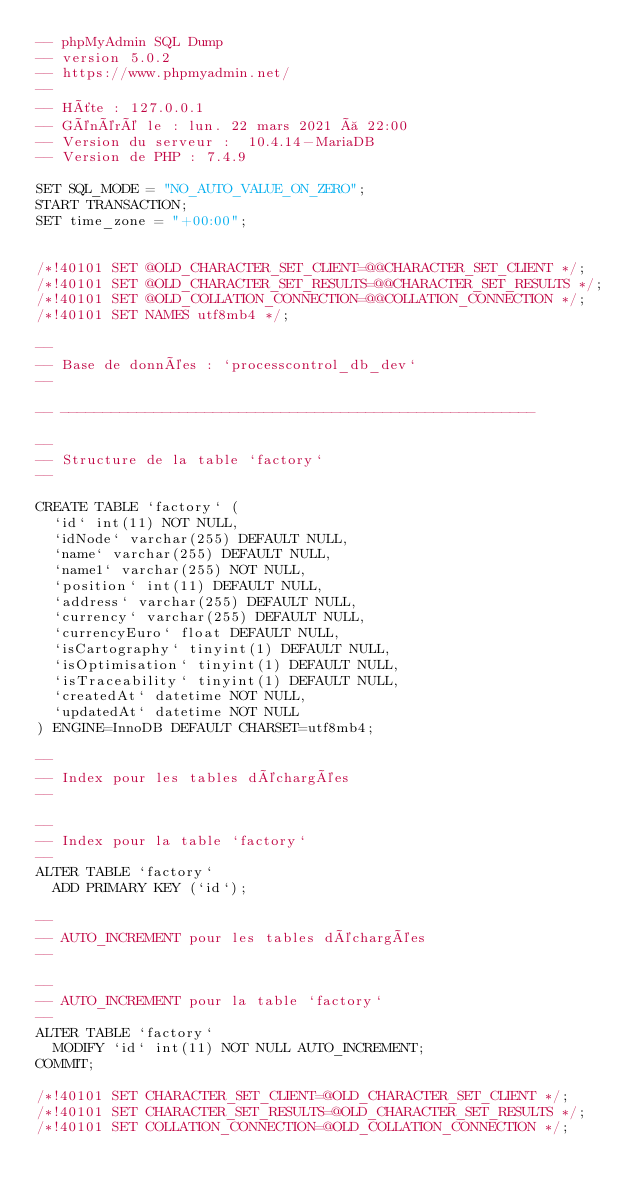Convert code to text. <code><loc_0><loc_0><loc_500><loc_500><_SQL_>-- phpMyAdmin SQL Dump
-- version 5.0.2
-- https://www.phpmyadmin.net/
--
-- Hôte : 127.0.0.1
-- Généré le : lun. 22 mars 2021 à 22:00
-- Version du serveur :  10.4.14-MariaDB
-- Version de PHP : 7.4.9

SET SQL_MODE = "NO_AUTO_VALUE_ON_ZERO";
START TRANSACTION;
SET time_zone = "+00:00";


/*!40101 SET @OLD_CHARACTER_SET_CLIENT=@@CHARACTER_SET_CLIENT */;
/*!40101 SET @OLD_CHARACTER_SET_RESULTS=@@CHARACTER_SET_RESULTS */;
/*!40101 SET @OLD_COLLATION_CONNECTION=@@COLLATION_CONNECTION */;
/*!40101 SET NAMES utf8mb4 */;

--
-- Base de données : `processcontrol_db_dev`
--

-- --------------------------------------------------------

--
-- Structure de la table `factory`
--

CREATE TABLE `factory` (
  `id` int(11) NOT NULL,
  `idNode` varchar(255) DEFAULT NULL,
  `name` varchar(255) DEFAULT NULL,
  `name1` varchar(255) NOT NULL,
  `position` int(11) DEFAULT NULL,
  `address` varchar(255) DEFAULT NULL,
  `currency` varchar(255) DEFAULT NULL,
  `currencyEuro` float DEFAULT NULL,
  `isCartography` tinyint(1) DEFAULT NULL,
  `isOptimisation` tinyint(1) DEFAULT NULL,
  `isTraceability` tinyint(1) DEFAULT NULL,
  `createdAt` datetime NOT NULL,
  `updatedAt` datetime NOT NULL
) ENGINE=InnoDB DEFAULT CHARSET=utf8mb4;

--
-- Index pour les tables déchargées
--

--
-- Index pour la table `factory`
--
ALTER TABLE `factory`
  ADD PRIMARY KEY (`id`);

--
-- AUTO_INCREMENT pour les tables déchargées
--

--
-- AUTO_INCREMENT pour la table `factory`
--
ALTER TABLE `factory`
  MODIFY `id` int(11) NOT NULL AUTO_INCREMENT;
COMMIT;

/*!40101 SET CHARACTER_SET_CLIENT=@OLD_CHARACTER_SET_CLIENT */;
/*!40101 SET CHARACTER_SET_RESULTS=@OLD_CHARACTER_SET_RESULTS */;
/*!40101 SET COLLATION_CONNECTION=@OLD_COLLATION_CONNECTION */;
</code> 